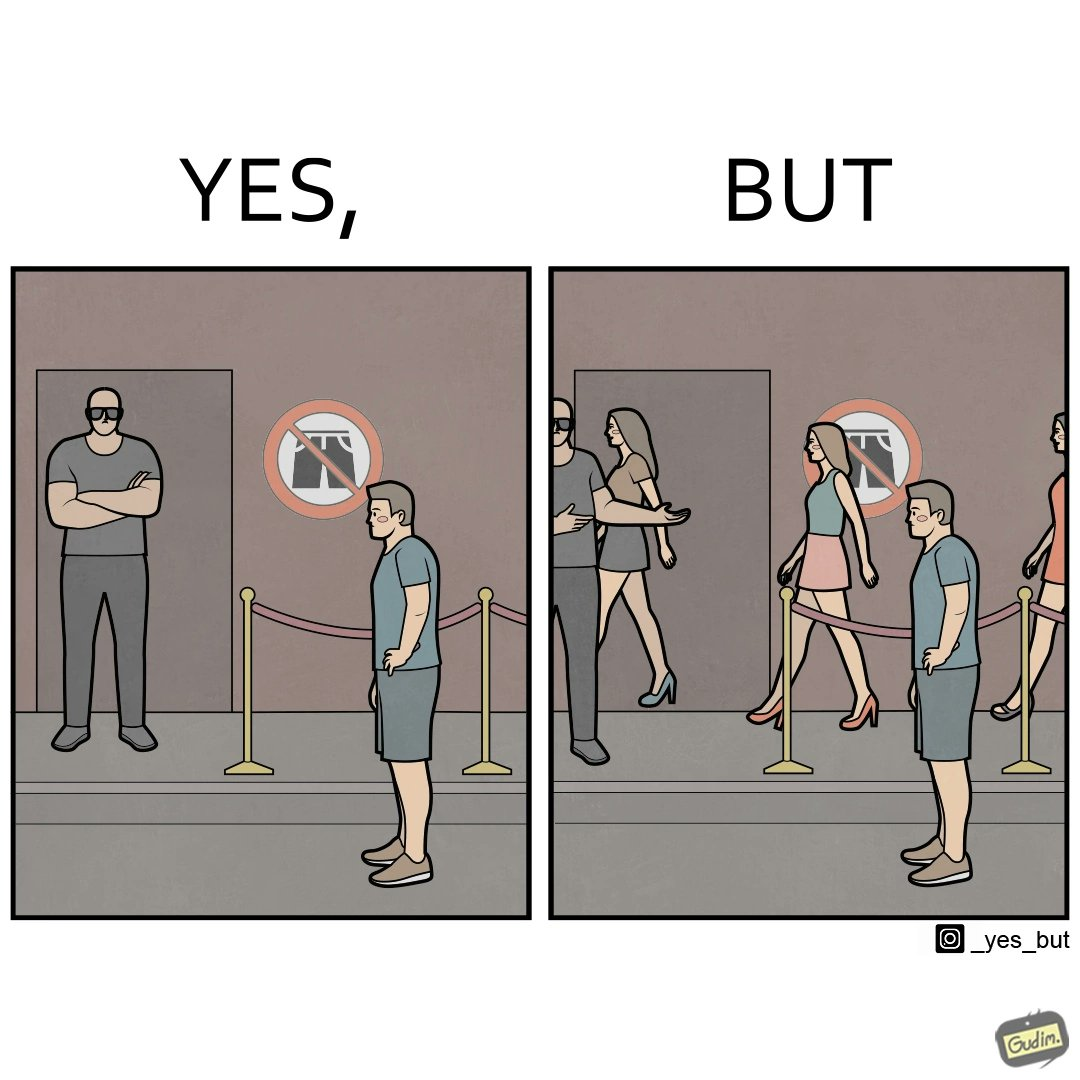What is shown in the left half versus the right half of this image? In the left part of the image: a man wearing shorts is not allowed at some hotel due to the prohibition board signaling no shorts allowed at the gate by the bodyguard at the gate In the right part of the image: a man wearing shorts is not allowed at some hotel due to the prohibition board signaling no shorts allowed at the gate by the bodyguard at the gate but many girls are entering the same hotel wearing shorts 